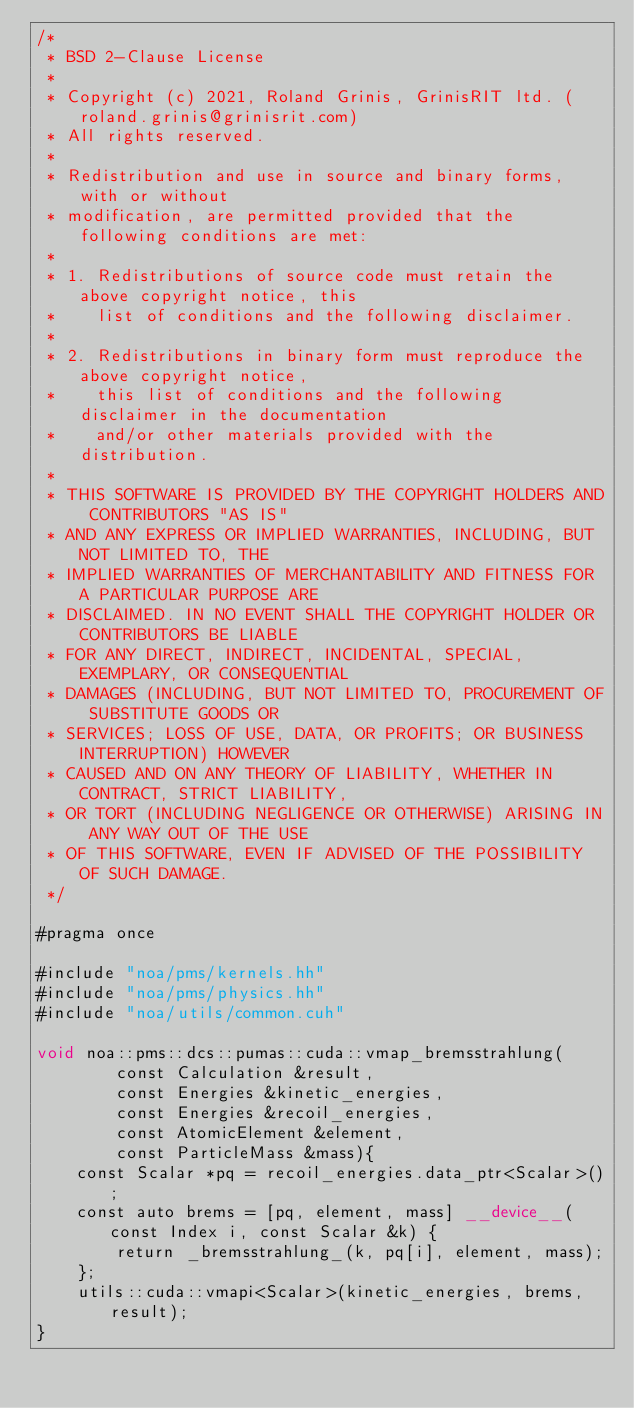Convert code to text. <code><loc_0><loc_0><loc_500><loc_500><_Cuda_>/*
 * BSD 2-Clause License
 *
 * Copyright (c) 2021, Roland Grinis, GrinisRIT ltd. (roland.grinis@grinisrit.com)
 * All rights reserved.
 *
 * Redistribution and use in source and binary forms, with or without
 * modification, are permitted provided that the following conditions are met:
 *
 * 1. Redistributions of source code must retain the above copyright notice, this
 *    list of conditions and the following disclaimer.
 *
 * 2. Redistributions in binary form must reproduce the above copyright notice,
 *    this list of conditions and the following disclaimer in the documentation
 *    and/or other materials provided with the distribution.
 *
 * THIS SOFTWARE IS PROVIDED BY THE COPYRIGHT HOLDERS AND CONTRIBUTORS "AS IS"
 * AND ANY EXPRESS OR IMPLIED WARRANTIES, INCLUDING, BUT NOT LIMITED TO, THE
 * IMPLIED WARRANTIES OF MERCHANTABILITY AND FITNESS FOR A PARTICULAR PURPOSE ARE
 * DISCLAIMED. IN NO EVENT SHALL THE COPYRIGHT HOLDER OR CONTRIBUTORS BE LIABLE
 * FOR ANY DIRECT, INDIRECT, INCIDENTAL, SPECIAL, EXEMPLARY, OR CONSEQUENTIAL
 * DAMAGES (INCLUDING, BUT NOT LIMITED TO, PROCUREMENT OF SUBSTITUTE GOODS OR
 * SERVICES; LOSS OF USE, DATA, OR PROFITS; OR BUSINESS INTERRUPTION) HOWEVER
 * CAUSED AND ON ANY THEORY OF LIABILITY, WHETHER IN CONTRACT, STRICT LIABILITY,
 * OR TORT (INCLUDING NEGLIGENCE OR OTHERWISE) ARISING IN ANY WAY OUT OF THE USE
 * OF THIS SOFTWARE, EVEN IF ADVISED OF THE POSSIBILITY OF SUCH DAMAGE.
 */

#pragma once

#include "noa/pms/kernels.hh"
#include "noa/pms/physics.hh"
#include "noa/utils/common.cuh"

void noa::pms::dcs::pumas::cuda::vmap_bremsstrahlung(
        const Calculation &result,
        const Energies &kinetic_energies,
        const Energies &recoil_energies,
        const AtomicElement &element,
        const ParticleMass &mass){
    const Scalar *pq = recoil_energies.data_ptr<Scalar>();
    const auto brems = [pq, element, mass] __device__(const Index i, const Scalar &k) {
        return _bremsstrahlung_(k, pq[i], element, mass);
    };
    utils::cuda::vmapi<Scalar>(kinetic_energies, brems, result);
}</code> 